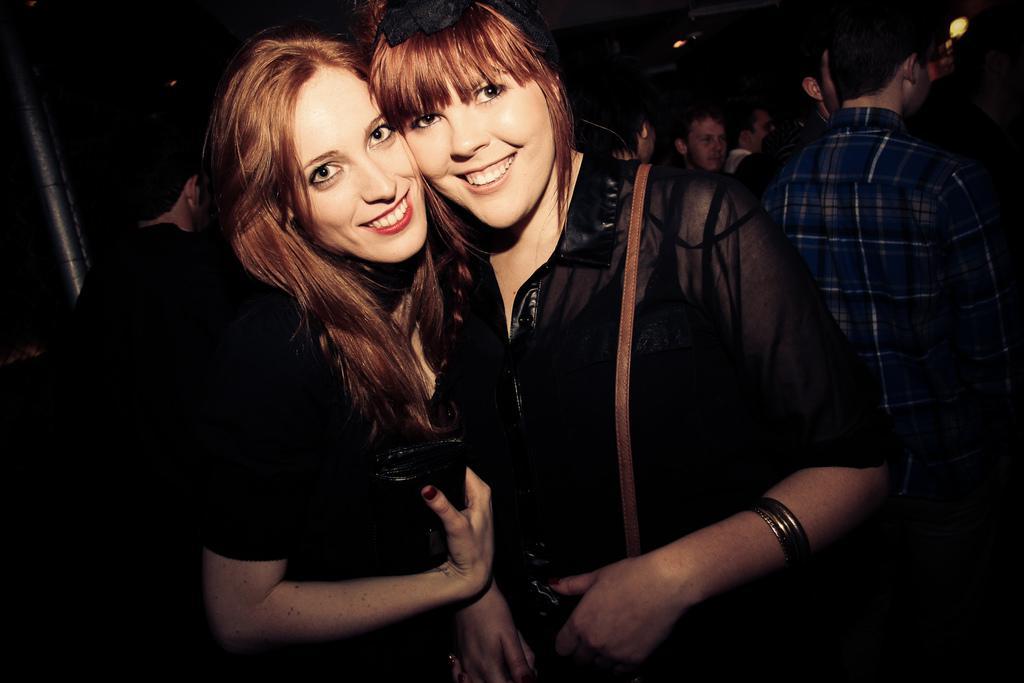In one or two sentences, can you explain what this image depicts? In this picture we can see two women smiling and at the back of them we can see a group of people standing and in the background it is dark. 